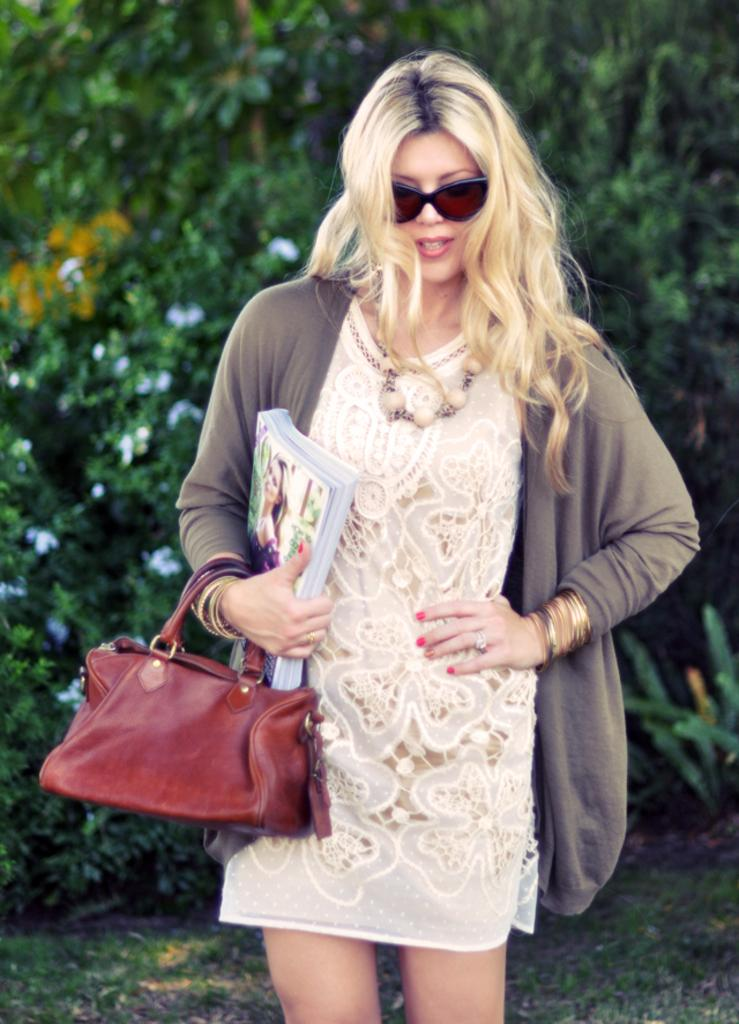Who is present in the image? There is a woman in the image. What is the woman holding in her hand? The woman is holding books in her hand. What else is the woman carrying? The woman is carrying a purse. What can be seen in the background of the image? There are trees visible in the background of the image. What type of vegetation covers the ground in the image? The ground is covered with grass. What type of wax can be seen dripping from the trees in the image? There is no wax visible in the image, nor is there any indication that wax is present or dripping from the trees. 